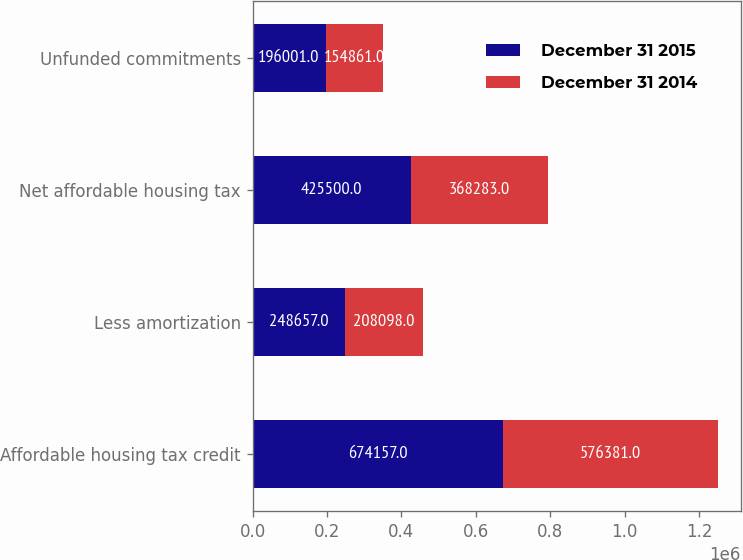<chart> <loc_0><loc_0><loc_500><loc_500><stacked_bar_chart><ecel><fcel>Affordable housing tax credit<fcel>Less amortization<fcel>Net affordable housing tax<fcel>Unfunded commitments<nl><fcel>December 31 2015<fcel>674157<fcel>248657<fcel>425500<fcel>196001<nl><fcel>December 31 2014<fcel>576381<fcel>208098<fcel>368283<fcel>154861<nl></chart> 